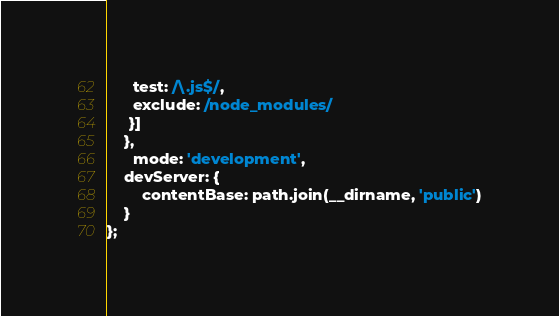<code> <loc_0><loc_0><loc_500><loc_500><_JavaScript_>      test: /\.js$/,
      exclude: /node_modules/
     }]
    },
      mode: 'development',
    devServer: {
        contentBase: path.join(__dirname, 'public')
    }
};</code> 